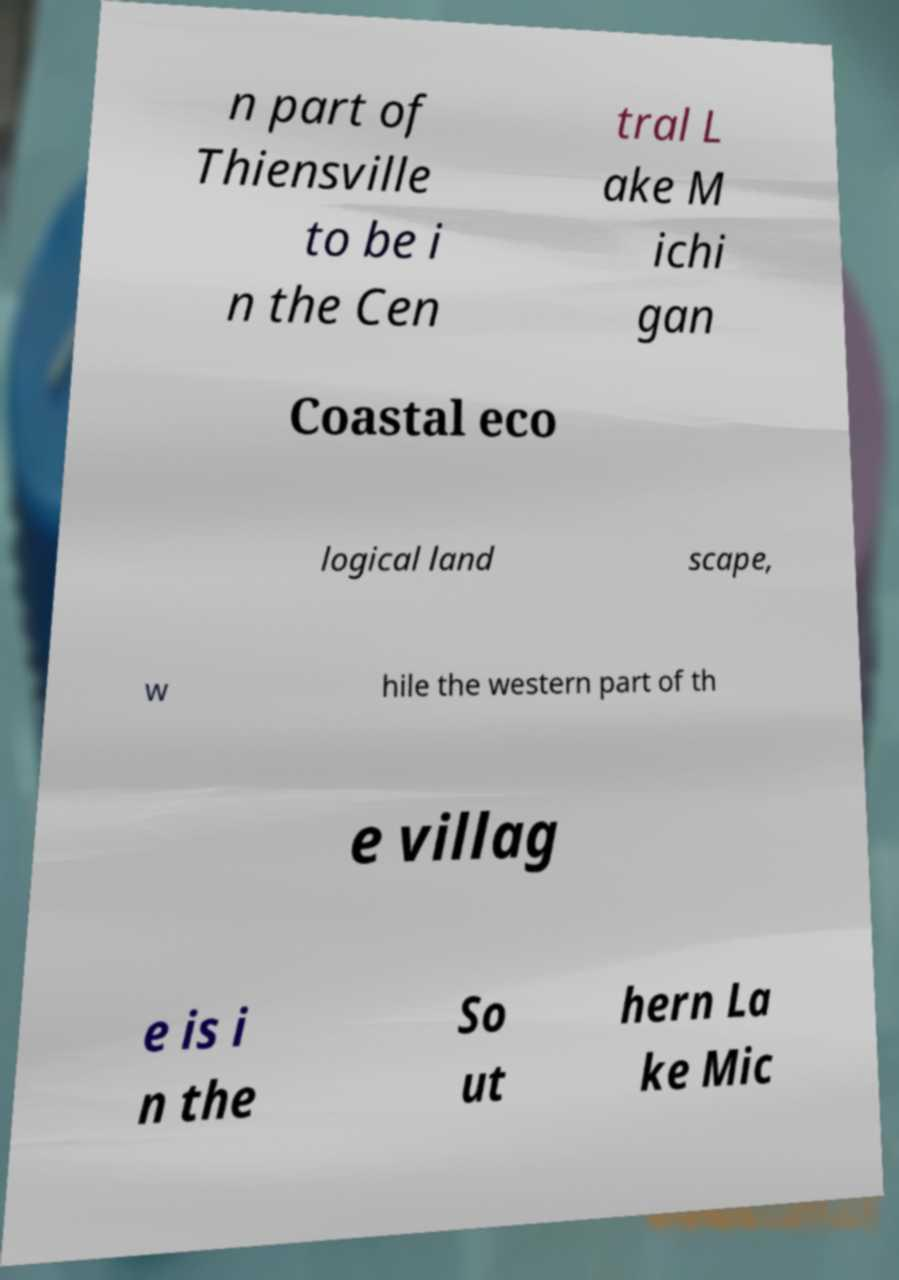Could you assist in decoding the text presented in this image and type it out clearly? n part of Thiensville to be i n the Cen tral L ake M ichi gan Coastal eco logical land scape, w hile the western part of th e villag e is i n the So ut hern La ke Mic 